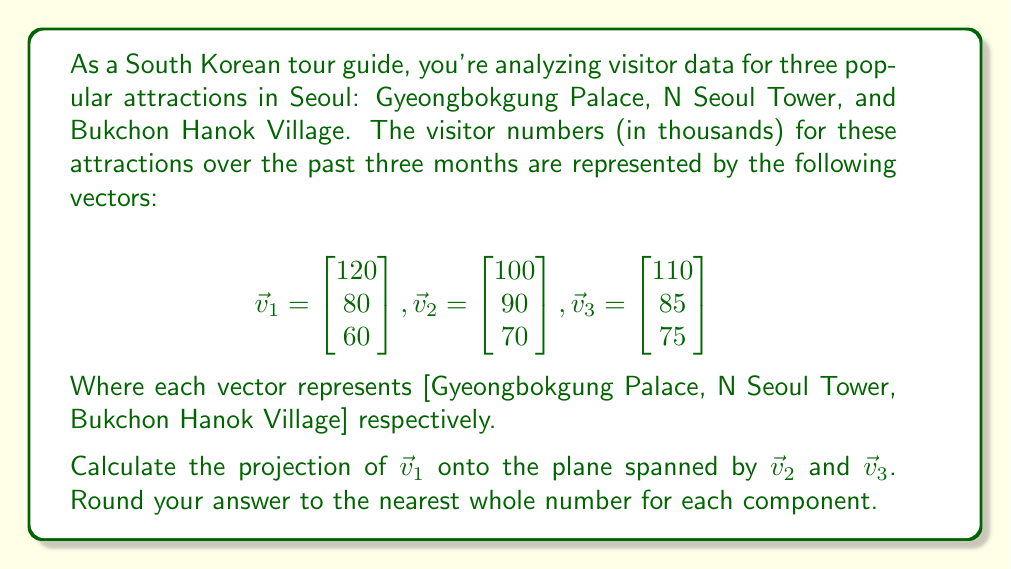Help me with this question. To solve this problem, we need to follow these steps:

1) First, we need to find an orthonormal basis for the plane spanned by $\vec{v}_2$ and $\vec{v}_3$. We can do this using the Gram-Schmidt process.

2) Let's call our orthonormal basis vectors $\vec{u}_1$ and $\vec{u}_2$.

3) Start with $\vec{v}_2$:
   $$\vec{u}_1 = \frac{\vec{v}_2}{\|\vec{v}_2\|} = \frac{1}{\sqrt{100^2 + 90^2 + 70^2}} \begin{bmatrix} 100 \\ 90 \\ 70 \end{bmatrix} \approx \begin{bmatrix} 0.6742 \\ 0.6068 \\ 0.4720 \end{bmatrix}$$

4) Now for $\vec{u}_2$, we need to subtract the projection of $\vec{v}_3$ onto $\vec{u}_1$:
   $$\vec{u}_2 = \vec{v}_3 - (\vec{v}_3 \cdot \vec{u}_1)\vec{u}_1$$
   $$= \begin{bmatrix} 110 \\ 85 \\ 75 \end{bmatrix} - (110 * 0.6742 + 85 * 0.6068 + 75 * 0.4720)\begin{bmatrix} 0.6742 \\ 0.6068 \\ 0.4720 \end{bmatrix}$$
   $$\approx \begin{bmatrix} 110 \\ 85 \\ 75 \end{bmatrix} - 181.6366 \begin{bmatrix} 0.6742 \\ 0.6068 \\ 0.4720 \end{bmatrix}$$
   $$\approx \begin{bmatrix} -12.4366 \\ -25.1628 \\ -10.7293 \end{bmatrix}$$

5) Normalize $\vec{u}_2$:
   $$\vec{u}_2 = \frac{\vec{u}_2}{\|\vec{u}_2\|} \approx \begin{bmatrix} -0.4054 \\ -0.8203 \\ -0.3497 \end{bmatrix}$$

6) Now we can project $\vec{v}_1$ onto this plane:
   $$\text{proj}_{\text{plane}}(\vec{v}_1) = (\vec{v}_1 \cdot \vec{u}_1)\vec{u}_1 + (\vec{v}_1 \cdot \vec{u}_2)\vec{u}_2$$

7) Calculate the dot products:
   $$\vec{v}_1 \cdot \vec{u}_1 = 120 * 0.6742 + 80 * 0.6068 + 60 * 0.4720 \approx 159.9984$$
   $$\vec{v}_1 \cdot \vec{u}_2 = 120 * (-0.4054) + 80 * (-0.8203) + 60 * (-0.3497) \approx -118.0016$$

8) Now we can compute the projection:
   $$\text{proj}_{\text{plane}}(\vec{v}_1) \approx 159.9984 \begin{bmatrix} 0.6742 \\ 0.6068 \\ 0.4720 \end{bmatrix} + (-118.0016) \begin{bmatrix} -0.4054 \\ -0.8203 \\ -0.3497 \end{bmatrix}$$
   $$\approx \begin{bmatrix} 107.8704 \\ 97.0871 \\ 75.5193 \end{bmatrix} + \begin{bmatrix} 47.8379 \\ 96.7987 \\ 41.2652 \end{bmatrix}$$
   $$\approx \begin{bmatrix} 155.7083 \\ 193.8858 \\ 116.7845 \end{bmatrix}$$

9) Rounding to the nearest whole number:
   $$\text{proj}_{\text{plane}}(\vec{v}_1) \approx \begin{bmatrix} 156 \\ 194 \\ 117 \end{bmatrix}$$
Answer: The projection of $\vec{v}_1$ onto the plane spanned by $\vec{v}_2$ and $\vec{v}_3$, rounded to the nearest whole number for each component, is:

$$\begin{bmatrix} 156 \\ 194 \\ 117 \end{bmatrix}$$ 